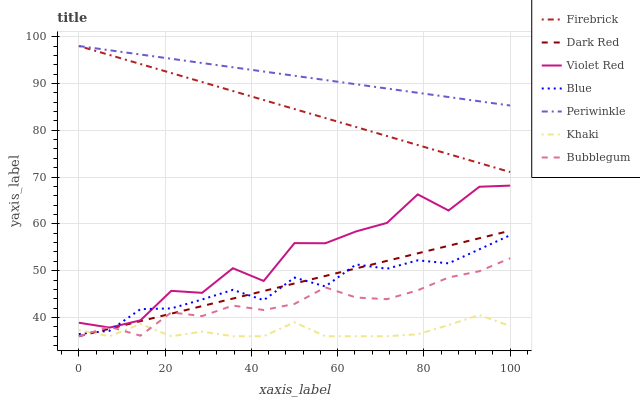Does Violet Red have the minimum area under the curve?
Answer yes or no. No. Does Violet Red have the maximum area under the curve?
Answer yes or no. No. Is Khaki the smoothest?
Answer yes or no. No. Is Khaki the roughest?
Answer yes or no. No. Does Violet Red have the lowest value?
Answer yes or no. No. Does Violet Red have the highest value?
Answer yes or no. No. Is Bubblegum less than Periwinkle?
Answer yes or no. Yes. Is Firebrick greater than Khaki?
Answer yes or no. Yes. Does Bubblegum intersect Periwinkle?
Answer yes or no. No. 